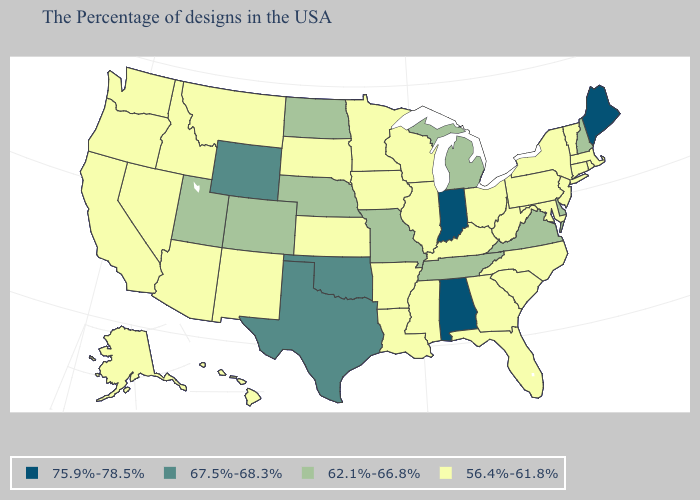What is the value of New Hampshire?
Quick response, please. 62.1%-66.8%. Name the states that have a value in the range 75.9%-78.5%?
Answer briefly. Maine, Indiana, Alabama. What is the lowest value in the MidWest?
Short answer required. 56.4%-61.8%. What is the value of Vermont?
Give a very brief answer. 56.4%-61.8%. What is the value of Wyoming?
Give a very brief answer. 67.5%-68.3%. Is the legend a continuous bar?
Quick response, please. No. What is the value of Minnesota?
Be succinct. 56.4%-61.8%. Name the states that have a value in the range 62.1%-66.8%?
Be succinct. New Hampshire, Delaware, Virginia, Michigan, Tennessee, Missouri, Nebraska, North Dakota, Colorado, Utah. Name the states that have a value in the range 67.5%-68.3%?
Short answer required. Oklahoma, Texas, Wyoming. What is the highest value in the South ?
Be succinct. 75.9%-78.5%. What is the lowest value in states that border Wisconsin?
Answer briefly. 56.4%-61.8%. What is the value of Washington?
Answer briefly. 56.4%-61.8%. What is the value of Wyoming?
Write a very short answer. 67.5%-68.3%. Does Michigan have a lower value than Maine?
Quick response, please. Yes. What is the value of Delaware?
Keep it brief. 62.1%-66.8%. 